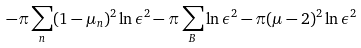Convert formula to latex. <formula><loc_0><loc_0><loc_500><loc_500>- \pi \sum _ { n } ( 1 - \mu _ { n } ) ^ { 2 } \ln \epsilon ^ { 2 } - \pi \sum _ { B } \ln \epsilon ^ { 2 } - \pi ( \mu - 2 ) ^ { 2 } \ln \epsilon ^ { 2 }</formula> 